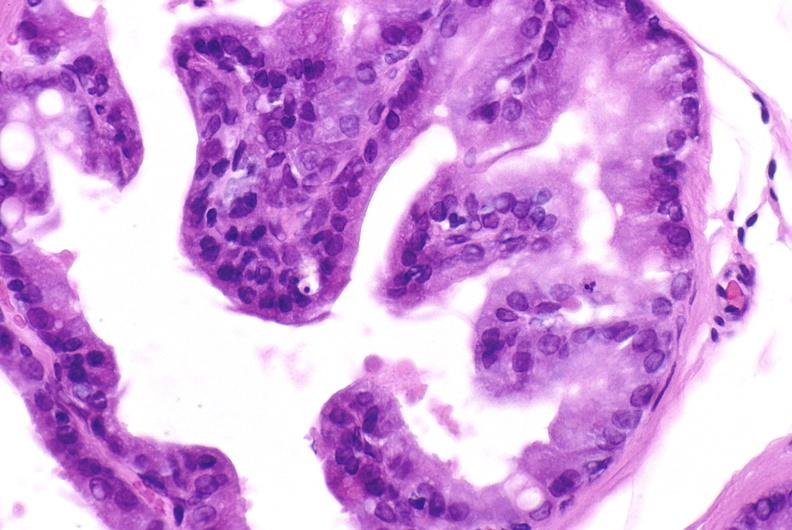when does this image show apoptosis in prostate?
Answer the question using a single word or phrase. After orchiectomy 